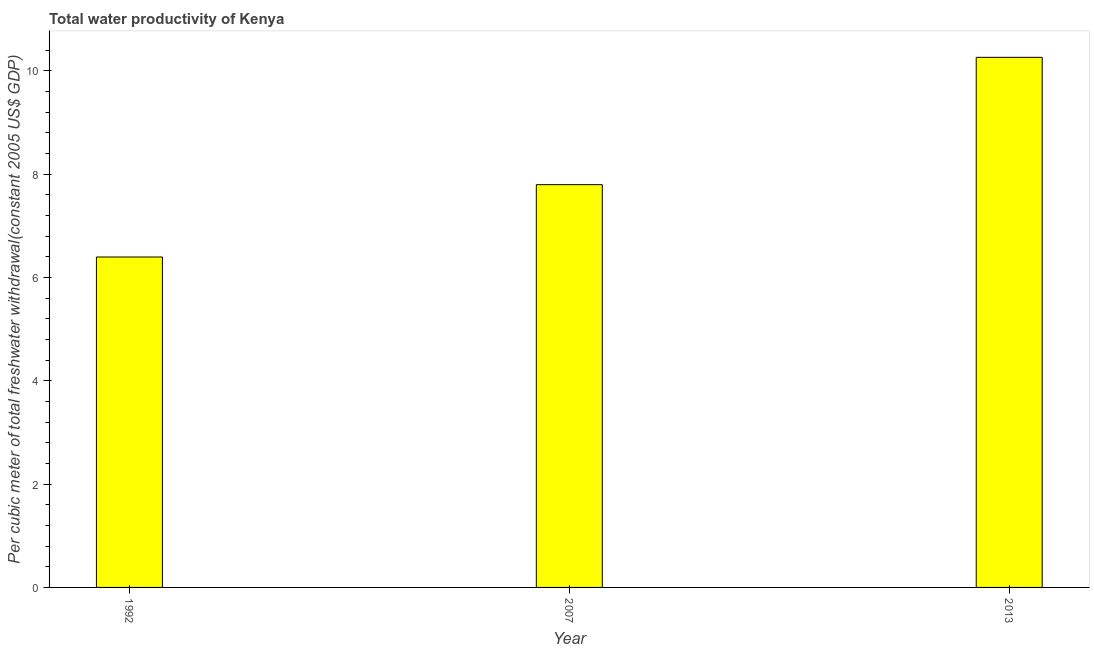Does the graph contain any zero values?
Make the answer very short. No. What is the title of the graph?
Your answer should be compact. Total water productivity of Kenya. What is the label or title of the Y-axis?
Provide a short and direct response. Per cubic meter of total freshwater withdrawal(constant 2005 US$ GDP). What is the total water productivity in 2007?
Your answer should be compact. 7.79. Across all years, what is the maximum total water productivity?
Make the answer very short. 10.26. Across all years, what is the minimum total water productivity?
Provide a short and direct response. 6.39. In which year was the total water productivity maximum?
Your answer should be compact. 2013. What is the sum of the total water productivity?
Make the answer very short. 24.45. What is the difference between the total water productivity in 2007 and 2013?
Your answer should be compact. -2.46. What is the average total water productivity per year?
Your answer should be very brief. 8.15. What is the median total water productivity?
Make the answer very short. 7.79. In how many years, is the total water productivity greater than 10 US$?
Offer a terse response. 1. What is the ratio of the total water productivity in 1992 to that in 2007?
Your answer should be very brief. 0.82. Is the difference between the total water productivity in 1992 and 2007 greater than the difference between any two years?
Give a very brief answer. No. What is the difference between the highest and the second highest total water productivity?
Provide a succinct answer. 2.46. What is the difference between the highest and the lowest total water productivity?
Offer a very short reply. 3.86. In how many years, is the total water productivity greater than the average total water productivity taken over all years?
Offer a very short reply. 1. How many bars are there?
Provide a short and direct response. 3. Are all the bars in the graph horizontal?
Offer a terse response. No. Are the values on the major ticks of Y-axis written in scientific E-notation?
Keep it short and to the point. No. What is the Per cubic meter of total freshwater withdrawal(constant 2005 US$ GDP) of 1992?
Ensure brevity in your answer.  6.39. What is the Per cubic meter of total freshwater withdrawal(constant 2005 US$ GDP) in 2007?
Your answer should be compact. 7.79. What is the Per cubic meter of total freshwater withdrawal(constant 2005 US$ GDP) of 2013?
Offer a very short reply. 10.26. What is the difference between the Per cubic meter of total freshwater withdrawal(constant 2005 US$ GDP) in 1992 and 2007?
Your answer should be compact. -1.4. What is the difference between the Per cubic meter of total freshwater withdrawal(constant 2005 US$ GDP) in 1992 and 2013?
Keep it short and to the point. -3.86. What is the difference between the Per cubic meter of total freshwater withdrawal(constant 2005 US$ GDP) in 2007 and 2013?
Offer a very short reply. -2.46. What is the ratio of the Per cubic meter of total freshwater withdrawal(constant 2005 US$ GDP) in 1992 to that in 2007?
Your response must be concise. 0.82. What is the ratio of the Per cubic meter of total freshwater withdrawal(constant 2005 US$ GDP) in 1992 to that in 2013?
Provide a succinct answer. 0.62. What is the ratio of the Per cubic meter of total freshwater withdrawal(constant 2005 US$ GDP) in 2007 to that in 2013?
Your answer should be compact. 0.76. 